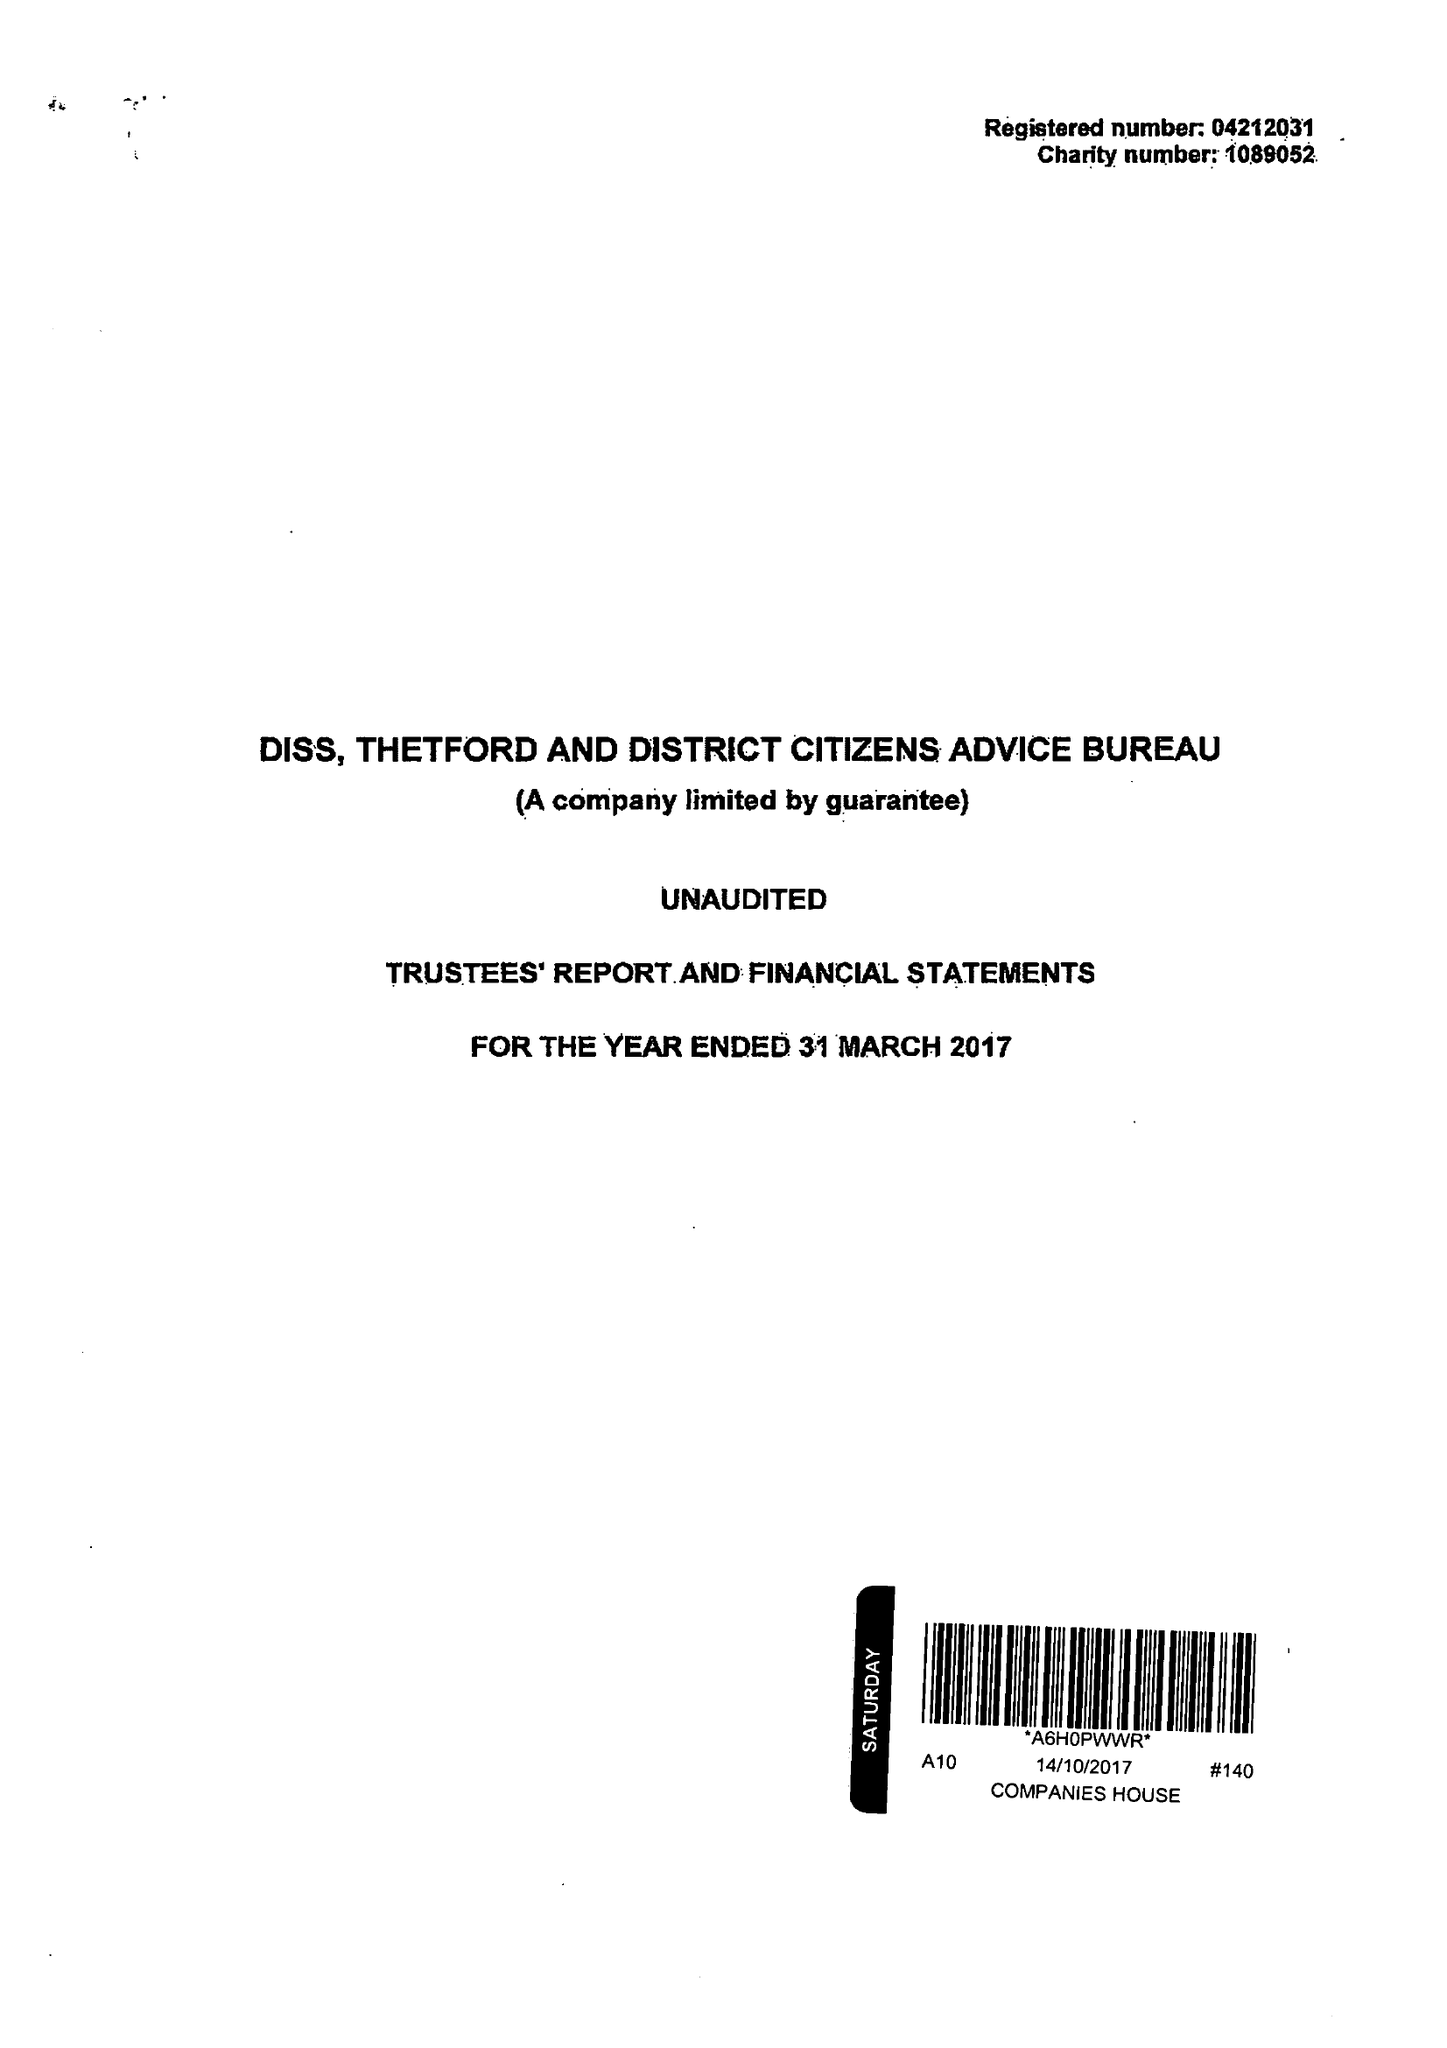What is the value for the address__street_line?
Answer the question using a single word or phrase. SHELFANGER ROAD 